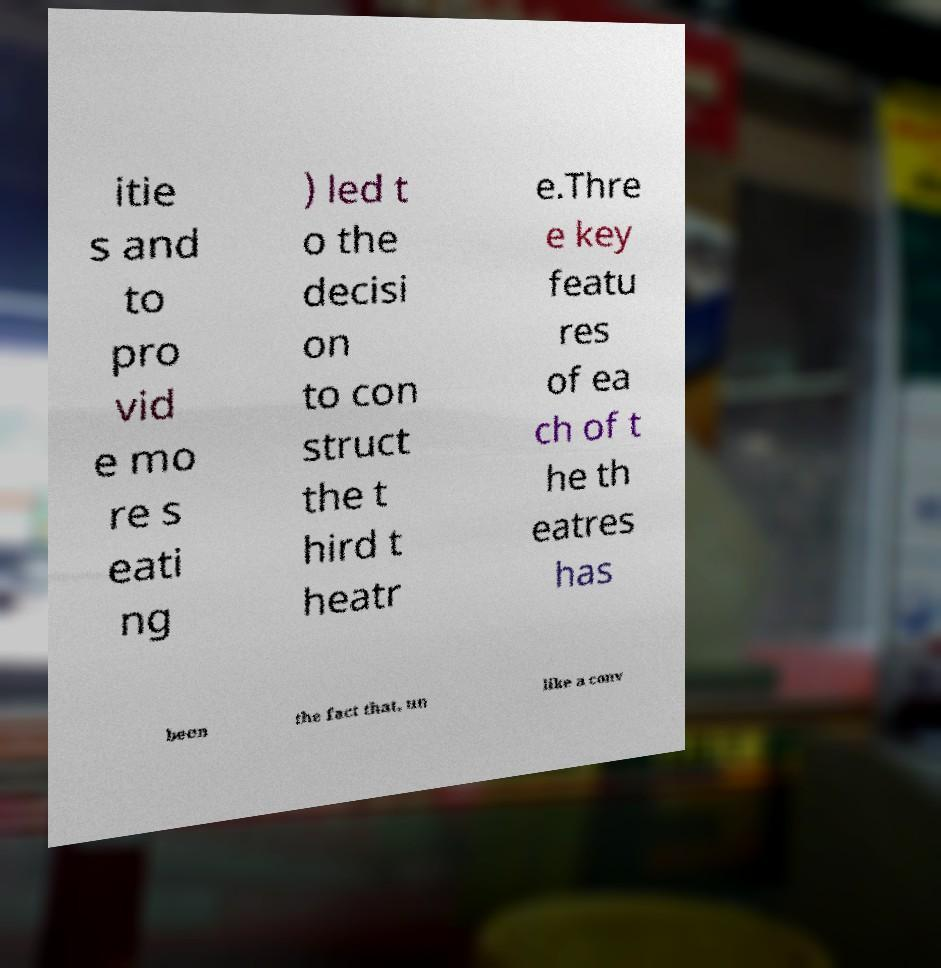What messages or text are displayed in this image? I need them in a readable, typed format. itie s and to pro vid e mo re s eati ng ) led t o the decisi on to con struct the t hird t heatr e.Thre e key featu res of ea ch of t he th eatres has been the fact that, un like a conv 